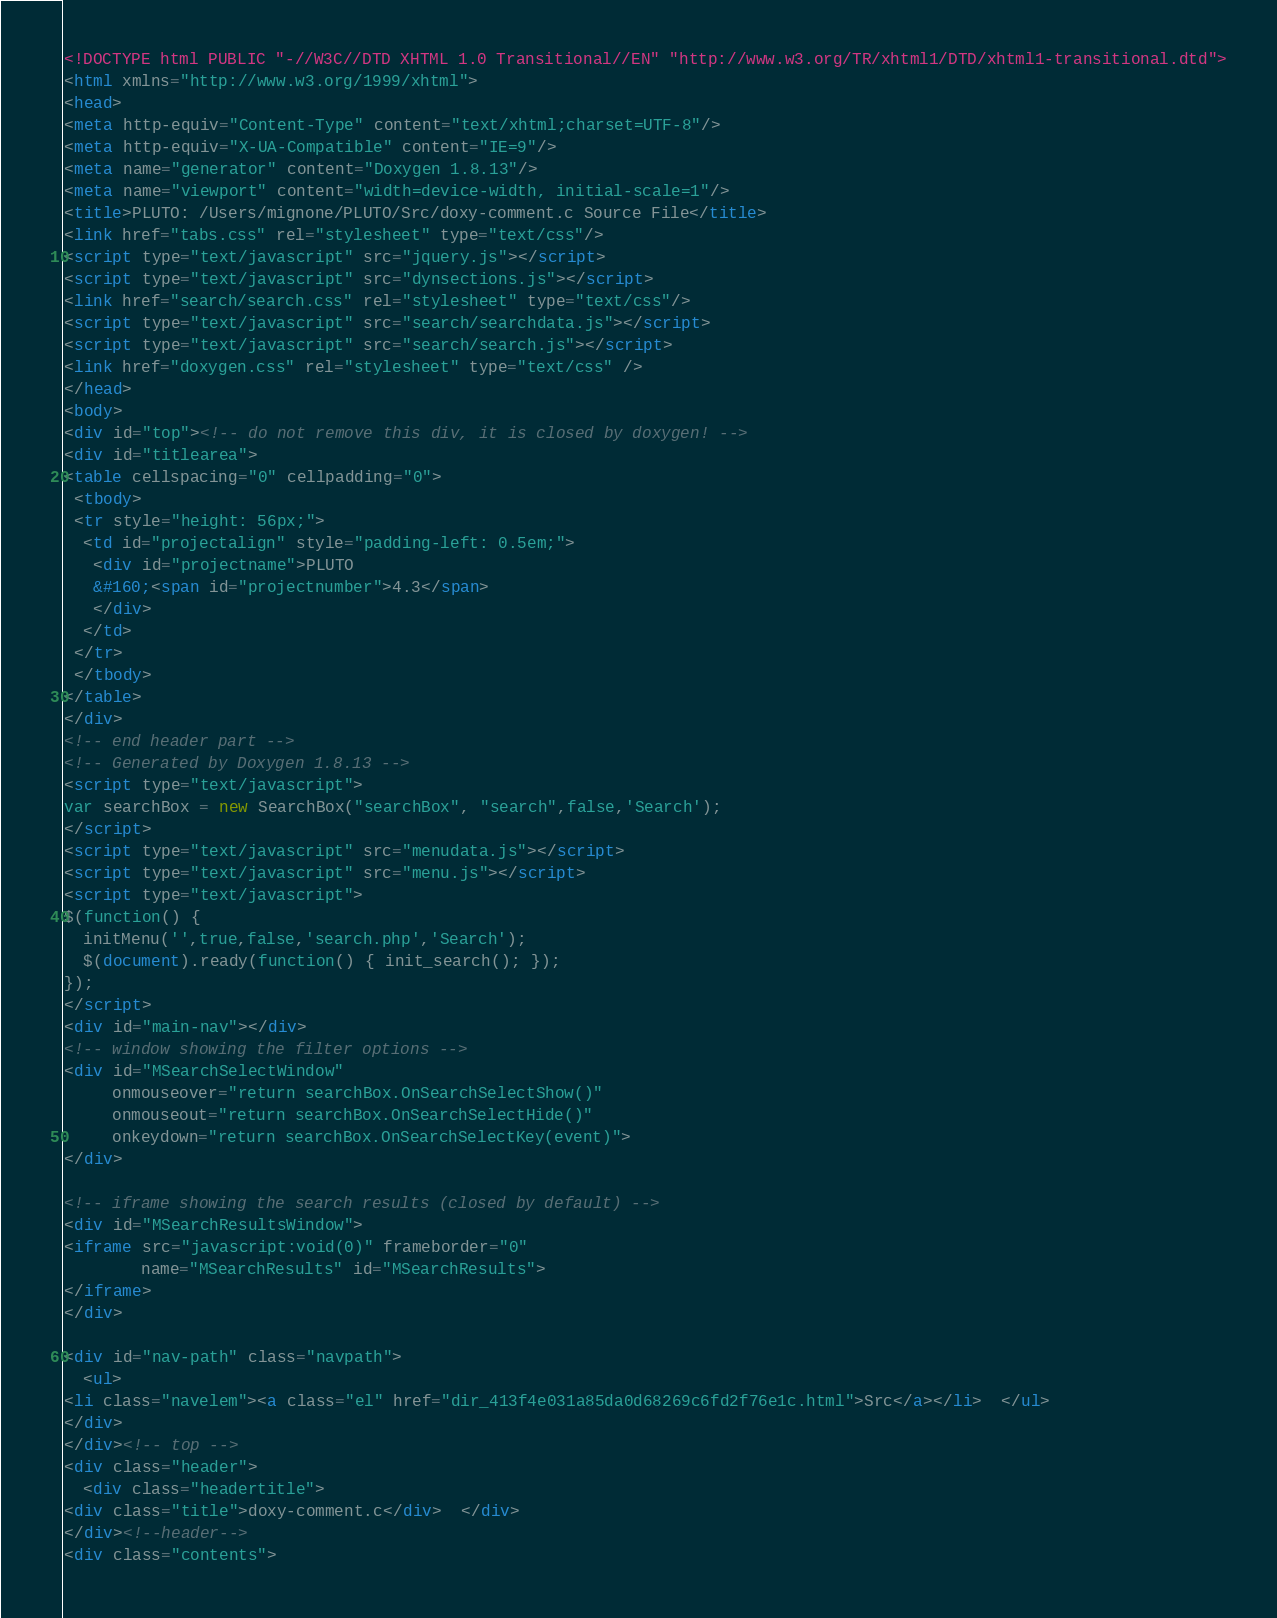<code> <loc_0><loc_0><loc_500><loc_500><_HTML_><!DOCTYPE html PUBLIC "-//W3C//DTD XHTML 1.0 Transitional//EN" "http://www.w3.org/TR/xhtml1/DTD/xhtml1-transitional.dtd">
<html xmlns="http://www.w3.org/1999/xhtml">
<head>
<meta http-equiv="Content-Type" content="text/xhtml;charset=UTF-8"/>
<meta http-equiv="X-UA-Compatible" content="IE=9"/>
<meta name="generator" content="Doxygen 1.8.13"/>
<meta name="viewport" content="width=device-width, initial-scale=1"/>
<title>PLUTO: /Users/mignone/PLUTO/Src/doxy-comment.c Source File</title>
<link href="tabs.css" rel="stylesheet" type="text/css"/>
<script type="text/javascript" src="jquery.js"></script>
<script type="text/javascript" src="dynsections.js"></script>
<link href="search/search.css" rel="stylesheet" type="text/css"/>
<script type="text/javascript" src="search/searchdata.js"></script>
<script type="text/javascript" src="search/search.js"></script>
<link href="doxygen.css" rel="stylesheet" type="text/css" />
</head>
<body>
<div id="top"><!-- do not remove this div, it is closed by doxygen! -->
<div id="titlearea">
<table cellspacing="0" cellpadding="0">
 <tbody>
 <tr style="height: 56px;">
  <td id="projectalign" style="padding-left: 0.5em;">
   <div id="projectname">PLUTO
   &#160;<span id="projectnumber">4.3</span>
   </div>
  </td>
 </tr>
 </tbody>
</table>
</div>
<!-- end header part -->
<!-- Generated by Doxygen 1.8.13 -->
<script type="text/javascript">
var searchBox = new SearchBox("searchBox", "search",false,'Search');
</script>
<script type="text/javascript" src="menudata.js"></script>
<script type="text/javascript" src="menu.js"></script>
<script type="text/javascript">
$(function() {
  initMenu('',true,false,'search.php','Search');
  $(document).ready(function() { init_search(); });
});
</script>
<div id="main-nav"></div>
<!-- window showing the filter options -->
<div id="MSearchSelectWindow"
     onmouseover="return searchBox.OnSearchSelectShow()"
     onmouseout="return searchBox.OnSearchSelectHide()"
     onkeydown="return searchBox.OnSearchSelectKey(event)">
</div>

<!-- iframe showing the search results (closed by default) -->
<div id="MSearchResultsWindow">
<iframe src="javascript:void(0)" frameborder="0" 
        name="MSearchResults" id="MSearchResults">
</iframe>
</div>

<div id="nav-path" class="navpath">
  <ul>
<li class="navelem"><a class="el" href="dir_413f4e031a85da0d68269c6fd2f76e1c.html">Src</a></li>  </ul>
</div>
</div><!-- top -->
<div class="header">
  <div class="headertitle">
<div class="title">doxy-comment.c</div>  </div>
</div><!--header-->
<div class="contents"></code> 